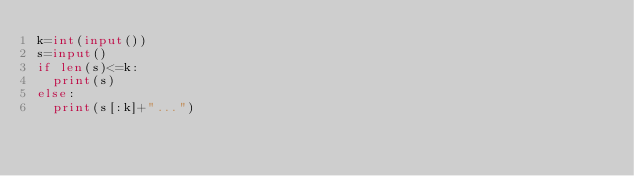Convert code to text. <code><loc_0><loc_0><loc_500><loc_500><_Python_>k=int(input())
s=input()
if len(s)<=k:
  print(s)
else:
  print(s[:k]+"...")</code> 